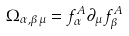<formula> <loc_0><loc_0><loc_500><loc_500>\Omega _ { \alpha , \beta \mu } = f _ { \alpha } ^ { A } \partial _ { \mu } f _ { \beta } ^ { A }</formula> 